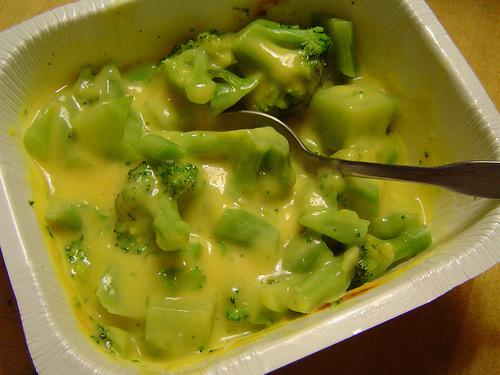How was this dish prepared?

Choices:
A) microwave
B) oven
C) grill
D) air fryer microwave 